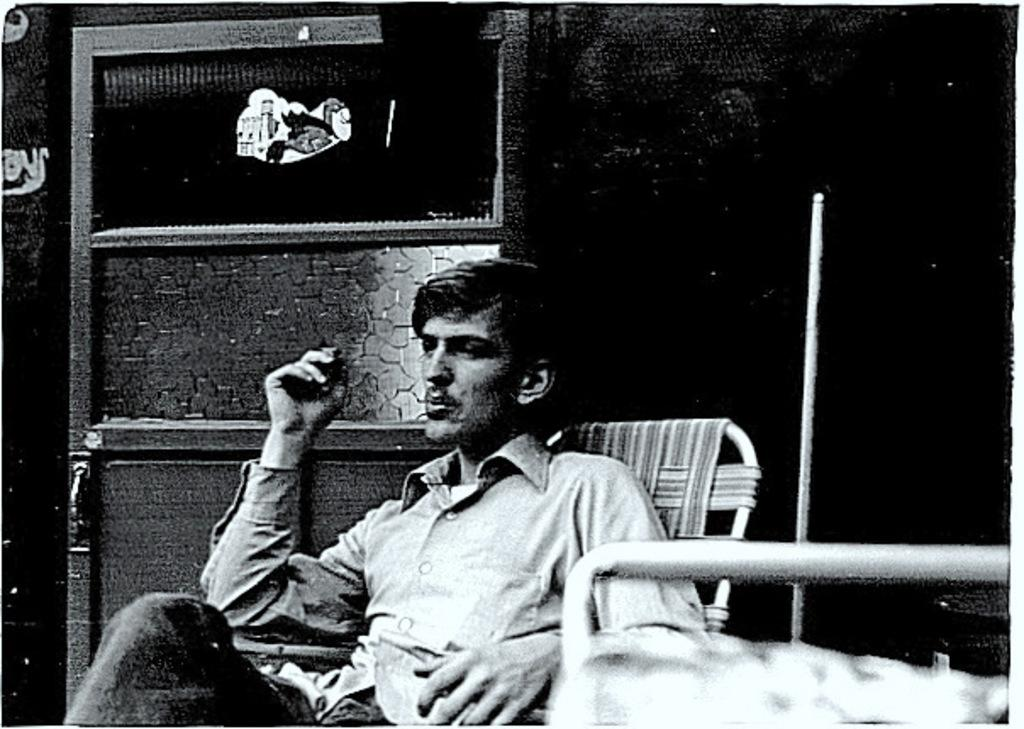Who or what is present in the image? There is a person in the image. What is the person wearing? The person is wearing a shirt and pants. What is the person doing in the image? The person is sitting on a chair. What can be seen in the background of the image? There is a wall and a door in the background of the image. What type of garden can be seen through the door in the image? There is no garden visible through the door in the image; only a wall and a door are present in the background. 